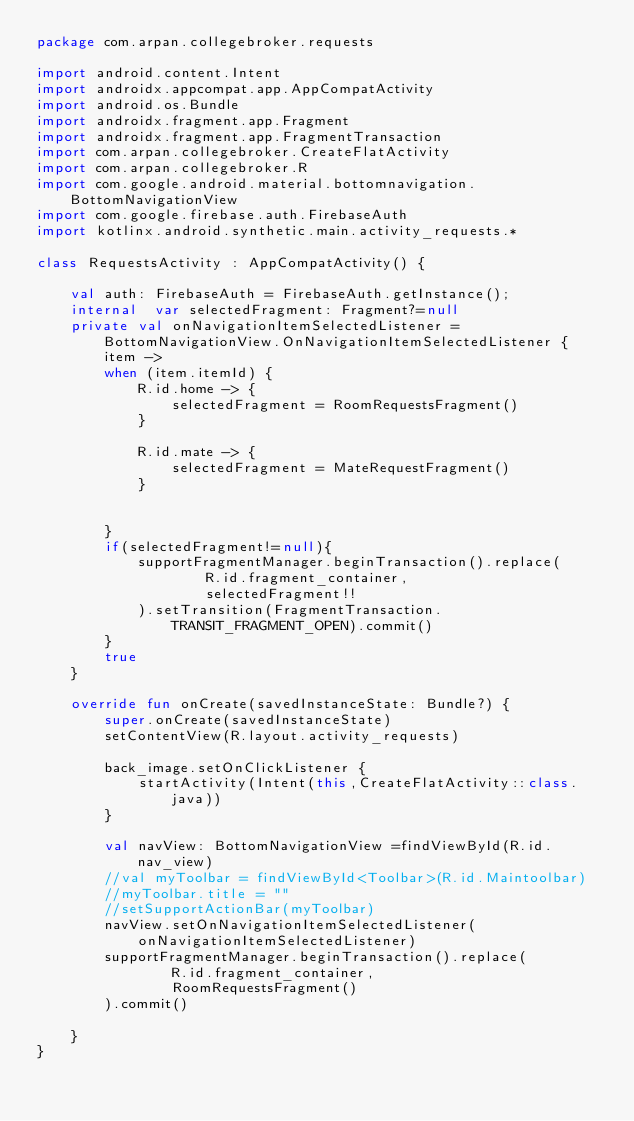<code> <loc_0><loc_0><loc_500><loc_500><_Kotlin_>package com.arpan.collegebroker.requests

import android.content.Intent
import androidx.appcompat.app.AppCompatActivity
import android.os.Bundle
import androidx.fragment.app.Fragment
import androidx.fragment.app.FragmentTransaction
import com.arpan.collegebroker.CreateFlatActivity
import com.arpan.collegebroker.R
import com.google.android.material.bottomnavigation.BottomNavigationView
import com.google.firebase.auth.FirebaseAuth
import kotlinx.android.synthetic.main.activity_requests.*

class RequestsActivity : AppCompatActivity() {

    val auth: FirebaseAuth = FirebaseAuth.getInstance();
    internal  var selectedFragment: Fragment?=null
    private val onNavigationItemSelectedListener = BottomNavigationView.OnNavigationItemSelectedListener { item ->
        when (item.itemId) {
            R.id.home -> {
                selectedFragment = RoomRequestsFragment()
            }

            R.id.mate -> {
                selectedFragment = MateRequestFragment()
            }


        }
        if(selectedFragment!=null){
            supportFragmentManager.beginTransaction().replace(
                    R.id.fragment_container,
                    selectedFragment!!
            ).setTransition(FragmentTransaction.TRANSIT_FRAGMENT_OPEN).commit()
        }
        true
    }

    override fun onCreate(savedInstanceState: Bundle?) {
        super.onCreate(savedInstanceState)
        setContentView(R.layout.activity_requests)

        back_image.setOnClickListener {
            startActivity(Intent(this,CreateFlatActivity::class.java))
        }

        val navView: BottomNavigationView =findViewById(R.id.nav_view)
        //val myToolbar = findViewById<Toolbar>(R.id.Maintoolbar)
        //myToolbar.title = ""
        //setSupportActionBar(myToolbar)
        navView.setOnNavigationItemSelectedListener(onNavigationItemSelectedListener)
        supportFragmentManager.beginTransaction().replace(
                R.id.fragment_container,
                RoomRequestsFragment()
        ).commit()

    }
}</code> 